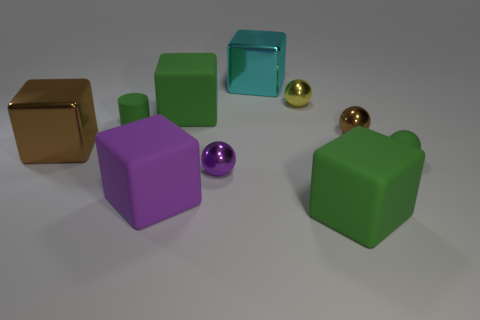Subtract 2 blocks. How many blocks are left? 3 Subtract all cyan cubes. How many cubes are left? 4 Subtract all cyan metal blocks. How many blocks are left? 4 Subtract all gray blocks. Subtract all blue cylinders. How many blocks are left? 5 Subtract all cylinders. How many objects are left? 9 Add 5 brown metal blocks. How many brown metal blocks are left? 6 Add 1 large cyan rubber cylinders. How many large cyan rubber cylinders exist? 1 Subtract 0 brown cylinders. How many objects are left? 10 Subtract all rubber things. Subtract all cyan objects. How many objects are left? 4 